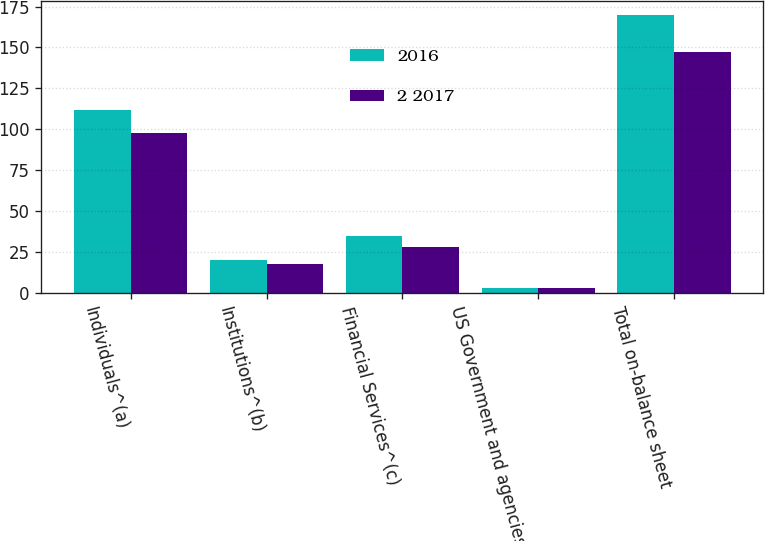Convert chart. <chart><loc_0><loc_0><loc_500><loc_500><stacked_bar_chart><ecel><fcel>Individuals^(a)<fcel>Institutions^(b)<fcel>Financial Services^(c)<fcel>US Government and agencies^(d)<fcel>Total on-balance sheet<nl><fcel>2016<fcel>112<fcel>20<fcel>35<fcel>3<fcel>170<nl><fcel>2 2017<fcel>98<fcel>18<fcel>28<fcel>3<fcel>147<nl></chart> 